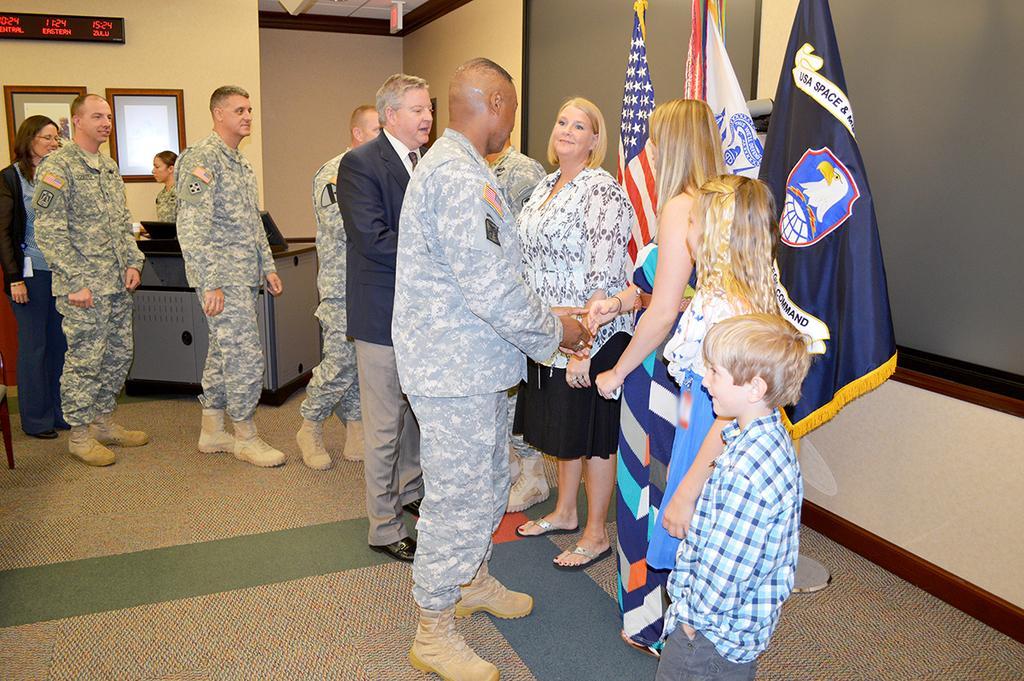In one or two sentences, can you explain what this image depicts? In this image there are persons standing on the floor. In this there are few people wearing uniform. Image also consists of frames attached to the wall and there is also a digital board with clock and text. There are three flags in this image. 